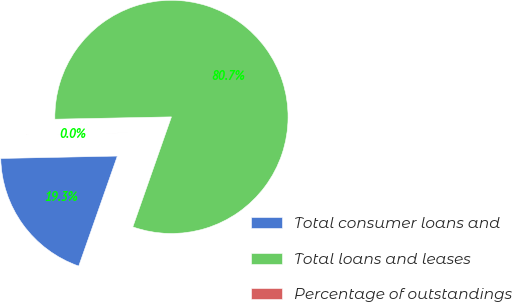Convert chart. <chart><loc_0><loc_0><loc_500><loc_500><pie_chart><fcel>Total consumer loans and<fcel>Total loans and leases<fcel>Percentage of outstandings<nl><fcel>19.3%<fcel>80.69%<fcel>0.01%<nl></chart> 